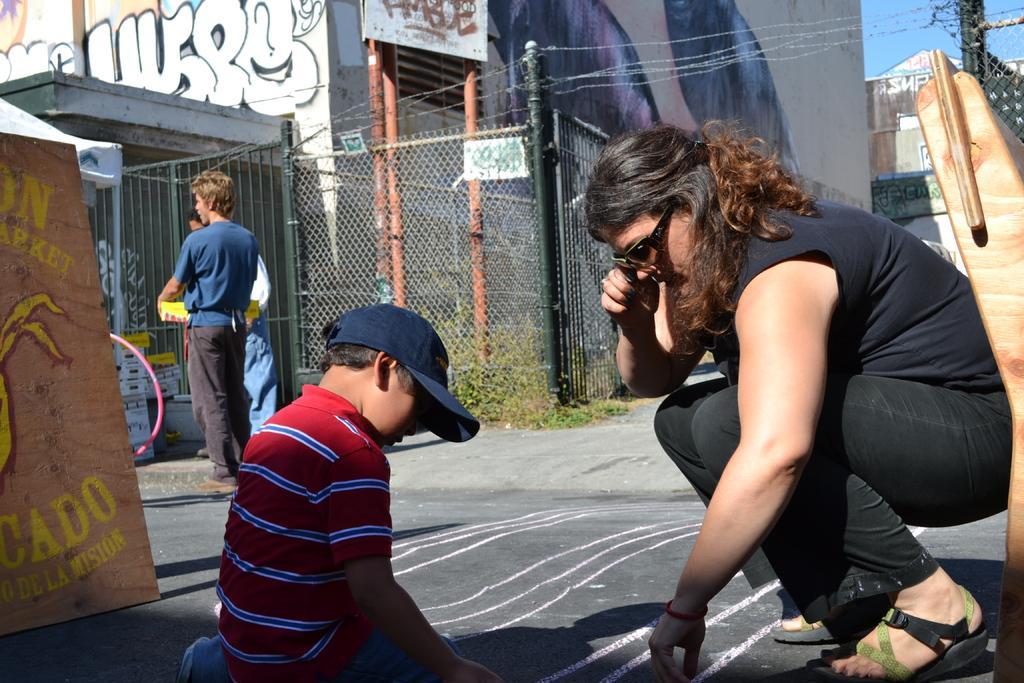Please provide a concise description of this image. In the center of the image we can see persons on the road. In the background we can see building and sky. 